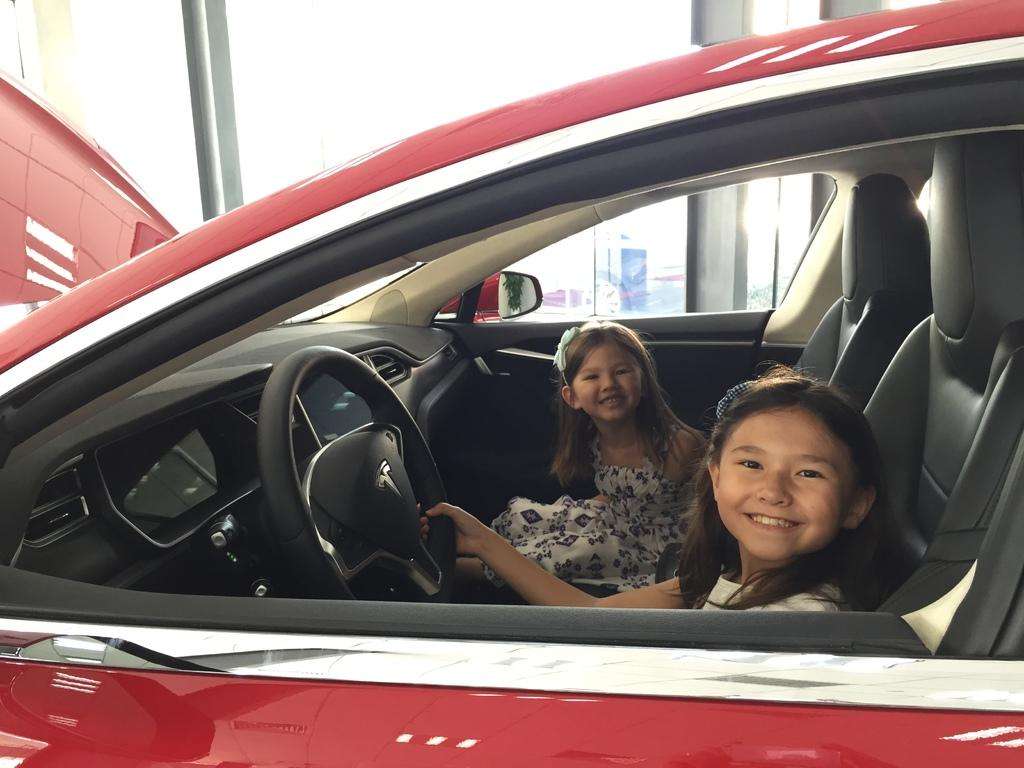How many people are sitting on car seats in the image? There are two persons sitting on car seats in the image. Can you describe the person on the right side? The person on the right side is a girl. What is the girl holding in the image? The girl is holding a steering wheel. What can be seen in the background of the image? There is a banner visible in the background, and the sky is also visible. What type of insurance policy does the girl have for the car in the image? There is no information about insurance policies in the image, as it only shows two persons sitting on car seats and a girl holding a steering wheel. 